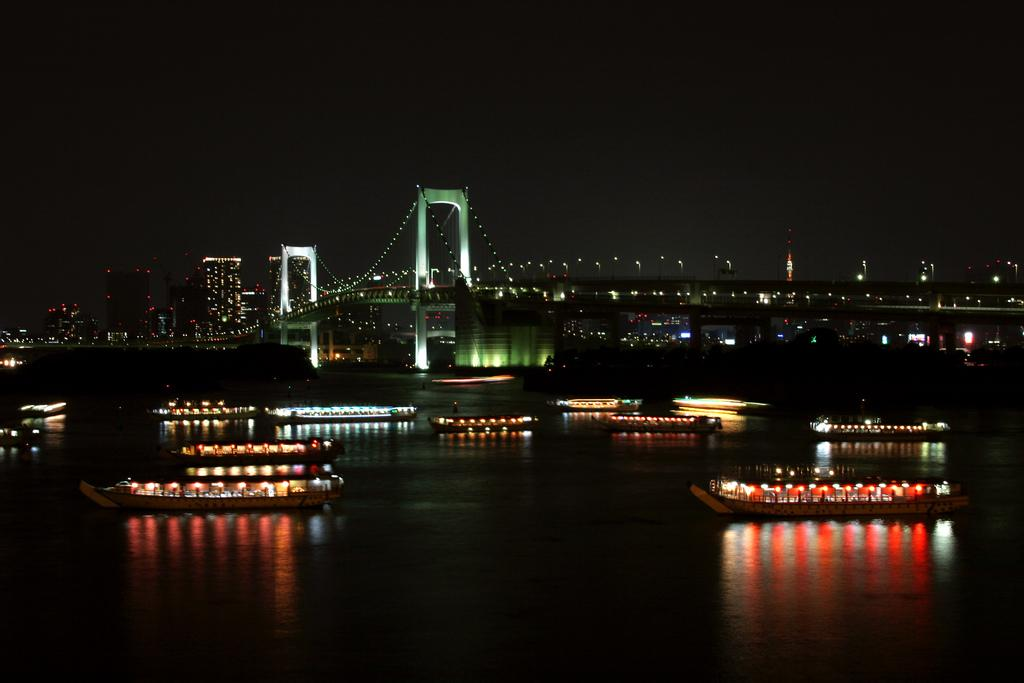What is the primary element in the image? There is water in the image. What is on the water in the image? There are boats on the water. What can be seen in the background of the image? There is a bridge, buildings, poles, lights, and the sky visible in the background of the image. What type of cloth is being used by the lawyer in the image? There is no lawyer or cloth present in the image. What legal process is being discussed in the image? There is no legal process or discussion present in the image. 